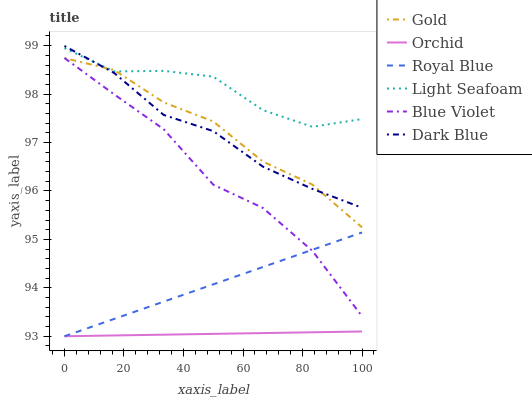Does Orchid have the minimum area under the curve?
Answer yes or no. Yes. Does Light Seafoam have the maximum area under the curve?
Answer yes or no. Yes. Does Dark Blue have the minimum area under the curve?
Answer yes or no. No. Does Dark Blue have the maximum area under the curve?
Answer yes or no. No. Is Orchid the smoothest?
Answer yes or no. Yes. Is Light Seafoam the roughest?
Answer yes or no. Yes. Is Dark Blue the smoothest?
Answer yes or no. No. Is Dark Blue the roughest?
Answer yes or no. No. Does Royal Blue have the lowest value?
Answer yes or no. Yes. Does Dark Blue have the lowest value?
Answer yes or no. No. Does Dark Blue have the highest value?
Answer yes or no. Yes. Does Royal Blue have the highest value?
Answer yes or no. No. Is Orchid less than Gold?
Answer yes or no. Yes. Is Light Seafoam greater than Blue Violet?
Answer yes or no. Yes. Does Blue Violet intersect Royal Blue?
Answer yes or no. Yes. Is Blue Violet less than Royal Blue?
Answer yes or no. No. Is Blue Violet greater than Royal Blue?
Answer yes or no. No. Does Orchid intersect Gold?
Answer yes or no. No. 